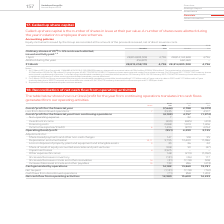From Vodafone Group Plc's financial document, Which financial years' information is shown in the table? The document shows two values: 2018 and 2019. From the document: "2019 2018 2019 2018..." Also, What is called up share capital? number of shares in issue at their par value. The document states: "Called up share capital is the number of shares in issue at their par value. A number of shares were allotted during the year in relation to employee ..." Also, How many ordinary shares were allotted during 2019? According to the financial document, 454,870. The relevant text states: "6 28,814,142,848 4,796 Allotted during the year 3 454,870 – 660,460 – 31 March 28,815,258,178 4,796 28,814,803,308 4,796..." Additionally, Between 2018 and 2019, which year had more ordinary shares allotted? According to the financial document, 2018. The relevant text states: "2019 2018..." Additionally, Between 2018 and 2019, which year had more ordinary shares as at 1 April? According to the financial document, 2019. The relevant text states: "2019 2018..." Also, can you calculate: What is the average number of ordinary shares as at 31 March for 2018 and 2019? To answer this question, I need to perform calculations using the financial data. The calculation is: (28,815,258,178+28,814,803,308)/2, which equals 28815030743. This is based on the information: "ach allotted, issued and fully paid: 1, 2 1 April 28,814,803,308 4,796 28,814,142,848 4,796 Allotted during the year 3 454,870 – 660,460 – 31 March 28,815,258,178 4 ed during the year 3 454,870 – 660,..." The key data points involved are: 28,814,803,308, 28,815,258,178. 